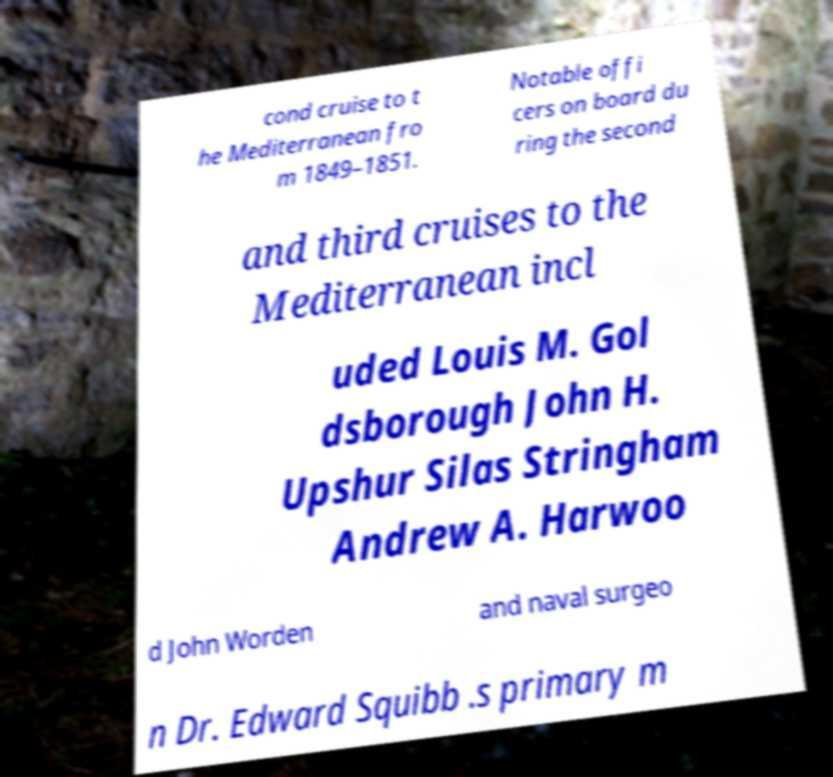Please read and relay the text visible in this image. What does it say? cond cruise to t he Mediterranean fro m 1849–1851. Notable offi cers on board du ring the second and third cruises to the Mediterranean incl uded Louis M. Gol dsborough John H. Upshur Silas Stringham Andrew A. Harwoo d John Worden and naval surgeo n Dr. Edward Squibb .s primary m 